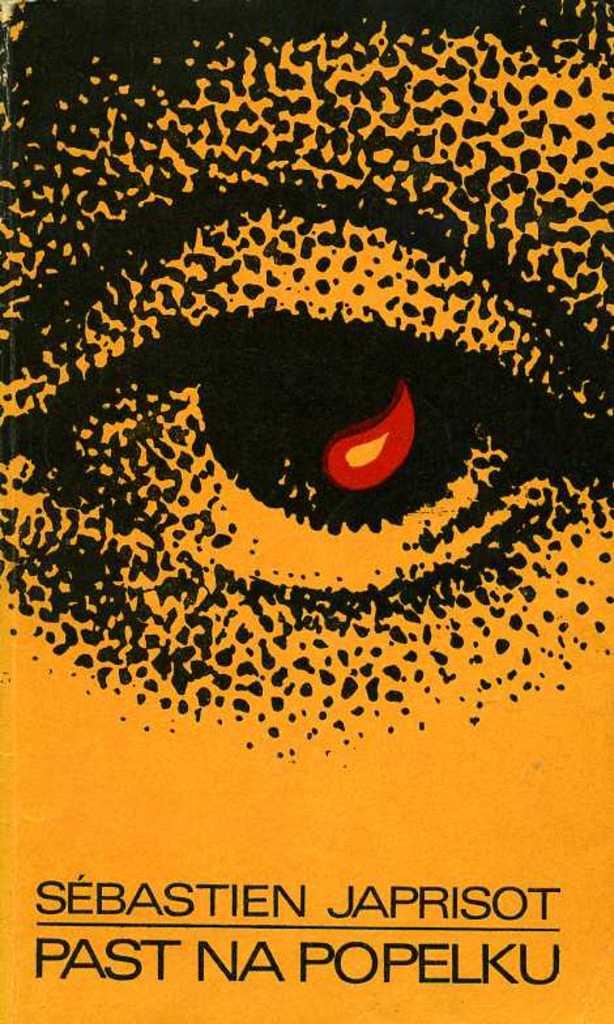What is sebastien's last name?
Make the answer very short. Japrisot. What is the title of this book?
Provide a succinct answer. Past na popelku. 